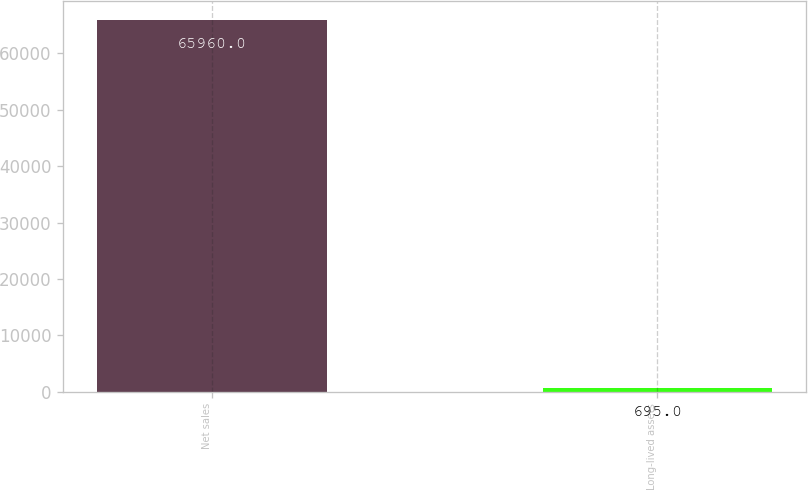Convert chart to OTSL. <chart><loc_0><loc_0><loc_500><loc_500><bar_chart><fcel>Net sales<fcel>Long-lived assets<nl><fcel>65960<fcel>695<nl></chart> 